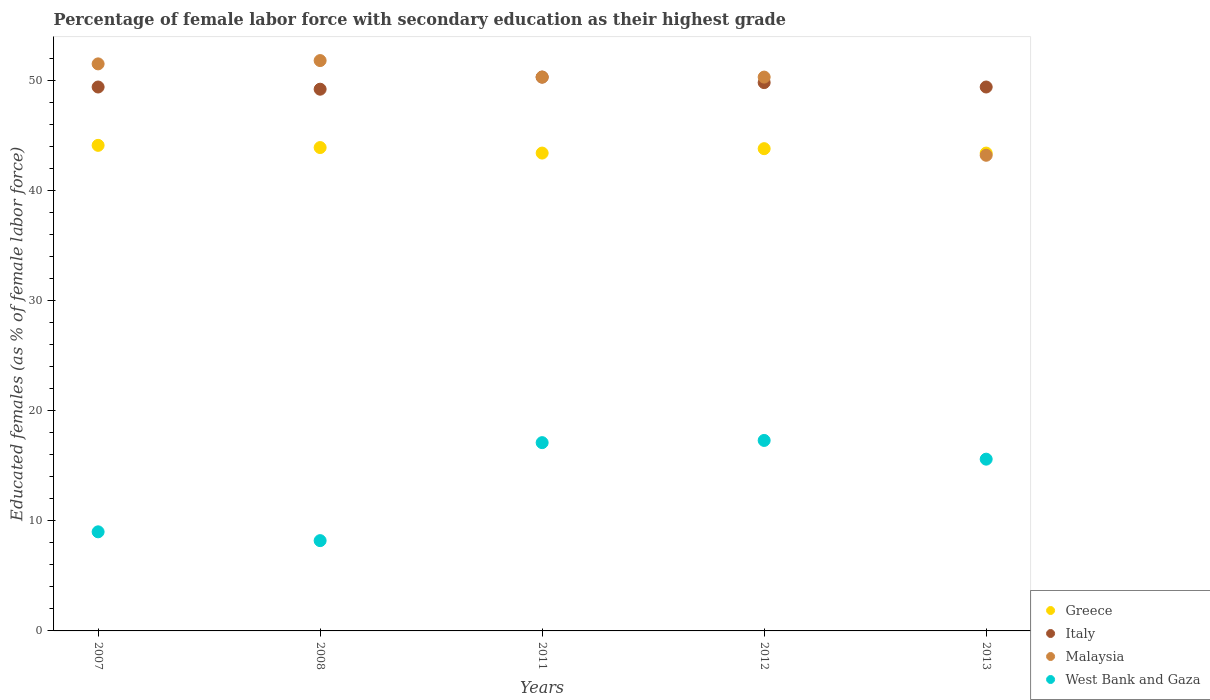Is the number of dotlines equal to the number of legend labels?
Make the answer very short. Yes. What is the percentage of female labor force with secondary education in Malaysia in 2013?
Offer a terse response. 43.2. Across all years, what is the maximum percentage of female labor force with secondary education in Italy?
Offer a very short reply. 50.3. Across all years, what is the minimum percentage of female labor force with secondary education in Italy?
Offer a terse response. 49.2. In which year was the percentage of female labor force with secondary education in Greece maximum?
Ensure brevity in your answer.  2007. In which year was the percentage of female labor force with secondary education in Italy minimum?
Your answer should be compact. 2008. What is the total percentage of female labor force with secondary education in West Bank and Gaza in the graph?
Provide a short and direct response. 67.2. What is the difference between the percentage of female labor force with secondary education in West Bank and Gaza in 2007 and that in 2013?
Ensure brevity in your answer.  -6.6. What is the difference between the percentage of female labor force with secondary education in West Bank and Gaza in 2011 and the percentage of female labor force with secondary education in Greece in 2012?
Make the answer very short. -26.7. What is the average percentage of female labor force with secondary education in Greece per year?
Keep it short and to the point. 43.72. In the year 2013, what is the difference between the percentage of female labor force with secondary education in Greece and percentage of female labor force with secondary education in West Bank and Gaza?
Provide a succinct answer. 27.8. In how many years, is the percentage of female labor force with secondary education in Malaysia greater than 26 %?
Your answer should be compact. 5. What is the ratio of the percentage of female labor force with secondary education in Greece in 2007 to that in 2008?
Offer a terse response. 1. Is the percentage of female labor force with secondary education in Italy in 2007 less than that in 2012?
Give a very brief answer. Yes. What is the difference between the highest and the second highest percentage of female labor force with secondary education in Greece?
Provide a succinct answer. 0.2. What is the difference between the highest and the lowest percentage of female labor force with secondary education in Malaysia?
Keep it short and to the point. 8.6. Is the sum of the percentage of female labor force with secondary education in West Bank and Gaza in 2011 and 2012 greater than the maximum percentage of female labor force with secondary education in Italy across all years?
Your answer should be very brief. No. Is it the case that in every year, the sum of the percentage of female labor force with secondary education in Malaysia and percentage of female labor force with secondary education in Italy  is greater than the sum of percentage of female labor force with secondary education in West Bank and Gaza and percentage of female labor force with secondary education in Greece?
Offer a very short reply. Yes. Does the percentage of female labor force with secondary education in West Bank and Gaza monotonically increase over the years?
Keep it short and to the point. No. Is the percentage of female labor force with secondary education in West Bank and Gaza strictly greater than the percentage of female labor force with secondary education in Greece over the years?
Ensure brevity in your answer.  No. What is the difference between two consecutive major ticks on the Y-axis?
Ensure brevity in your answer.  10. How many legend labels are there?
Provide a succinct answer. 4. How are the legend labels stacked?
Your answer should be very brief. Vertical. What is the title of the graph?
Provide a succinct answer. Percentage of female labor force with secondary education as their highest grade. What is the label or title of the X-axis?
Offer a very short reply. Years. What is the label or title of the Y-axis?
Offer a terse response. Educated females (as % of female labor force). What is the Educated females (as % of female labor force) in Greece in 2007?
Make the answer very short. 44.1. What is the Educated females (as % of female labor force) in Italy in 2007?
Give a very brief answer. 49.4. What is the Educated females (as % of female labor force) in Malaysia in 2007?
Offer a very short reply. 51.5. What is the Educated females (as % of female labor force) of West Bank and Gaza in 2007?
Your answer should be compact. 9. What is the Educated females (as % of female labor force) of Greece in 2008?
Provide a succinct answer. 43.9. What is the Educated females (as % of female labor force) in Italy in 2008?
Keep it short and to the point. 49.2. What is the Educated females (as % of female labor force) of Malaysia in 2008?
Give a very brief answer. 51.8. What is the Educated females (as % of female labor force) in West Bank and Gaza in 2008?
Provide a succinct answer. 8.2. What is the Educated females (as % of female labor force) in Greece in 2011?
Give a very brief answer. 43.4. What is the Educated females (as % of female labor force) of Italy in 2011?
Offer a very short reply. 50.3. What is the Educated females (as % of female labor force) of Malaysia in 2011?
Provide a short and direct response. 50.3. What is the Educated females (as % of female labor force) in West Bank and Gaza in 2011?
Offer a very short reply. 17.1. What is the Educated females (as % of female labor force) of Greece in 2012?
Ensure brevity in your answer.  43.8. What is the Educated females (as % of female labor force) of Italy in 2012?
Ensure brevity in your answer.  49.8. What is the Educated females (as % of female labor force) in Malaysia in 2012?
Provide a succinct answer. 50.3. What is the Educated females (as % of female labor force) of West Bank and Gaza in 2012?
Offer a very short reply. 17.3. What is the Educated females (as % of female labor force) in Greece in 2013?
Make the answer very short. 43.4. What is the Educated females (as % of female labor force) of Italy in 2013?
Provide a short and direct response. 49.4. What is the Educated females (as % of female labor force) in Malaysia in 2013?
Offer a very short reply. 43.2. What is the Educated females (as % of female labor force) of West Bank and Gaza in 2013?
Your response must be concise. 15.6. Across all years, what is the maximum Educated females (as % of female labor force) in Greece?
Keep it short and to the point. 44.1. Across all years, what is the maximum Educated females (as % of female labor force) of Italy?
Provide a succinct answer. 50.3. Across all years, what is the maximum Educated females (as % of female labor force) of Malaysia?
Your response must be concise. 51.8. Across all years, what is the maximum Educated females (as % of female labor force) in West Bank and Gaza?
Ensure brevity in your answer.  17.3. Across all years, what is the minimum Educated females (as % of female labor force) in Greece?
Provide a short and direct response. 43.4. Across all years, what is the minimum Educated females (as % of female labor force) in Italy?
Your response must be concise. 49.2. Across all years, what is the minimum Educated females (as % of female labor force) in Malaysia?
Give a very brief answer. 43.2. Across all years, what is the minimum Educated females (as % of female labor force) of West Bank and Gaza?
Keep it short and to the point. 8.2. What is the total Educated females (as % of female labor force) in Greece in the graph?
Offer a terse response. 218.6. What is the total Educated females (as % of female labor force) in Italy in the graph?
Provide a short and direct response. 248.1. What is the total Educated females (as % of female labor force) of Malaysia in the graph?
Your answer should be compact. 247.1. What is the total Educated females (as % of female labor force) of West Bank and Gaza in the graph?
Make the answer very short. 67.2. What is the difference between the Educated females (as % of female labor force) in Greece in 2007 and that in 2008?
Offer a very short reply. 0.2. What is the difference between the Educated females (as % of female labor force) in Italy in 2007 and that in 2008?
Provide a succinct answer. 0.2. What is the difference between the Educated females (as % of female labor force) of Malaysia in 2007 and that in 2008?
Make the answer very short. -0.3. What is the difference between the Educated females (as % of female labor force) of Greece in 2007 and that in 2011?
Offer a very short reply. 0.7. What is the difference between the Educated females (as % of female labor force) in Italy in 2007 and that in 2011?
Provide a short and direct response. -0.9. What is the difference between the Educated females (as % of female labor force) of Malaysia in 2007 and that in 2011?
Give a very brief answer. 1.2. What is the difference between the Educated females (as % of female labor force) of West Bank and Gaza in 2007 and that in 2011?
Provide a short and direct response. -8.1. What is the difference between the Educated females (as % of female labor force) in Malaysia in 2007 and that in 2012?
Your answer should be very brief. 1.2. What is the difference between the Educated females (as % of female labor force) of Italy in 2007 and that in 2013?
Provide a succinct answer. 0. What is the difference between the Educated females (as % of female labor force) in Malaysia in 2007 and that in 2013?
Offer a very short reply. 8.3. What is the difference between the Educated females (as % of female labor force) in West Bank and Gaza in 2007 and that in 2013?
Keep it short and to the point. -6.6. What is the difference between the Educated females (as % of female labor force) in Greece in 2008 and that in 2011?
Provide a short and direct response. 0.5. What is the difference between the Educated females (as % of female labor force) of Italy in 2008 and that in 2011?
Make the answer very short. -1.1. What is the difference between the Educated females (as % of female labor force) in West Bank and Gaza in 2008 and that in 2011?
Ensure brevity in your answer.  -8.9. What is the difference between the Educated females (as % of female labor force) of Greece in 2008 and that in 2012?
Your answer should be compact. 0.1. What is the difference between the Educated females (as % of female labor force) of Italy in 2008 and that in 2012?
Give a very brief answer. -0.6. What is the difference between the Educated females (as % of female labor force) of West Bank and Gaza in 2008 and that in 2012?
Offer a terse response. -9.1. What is the difference between the Educated females (as % of female labor force) of Greece in 2008 and that in 2013?
Ensure brevity in your answer.  0.5. What is the difference between the Educated females (as % of female labor force) in West Bank and Gaza in 2008 and that in 2013?
Your answer should be compact. -7.4. What is the difference between the Educated females (as % of female labor force) in Greece in 2011 and that in 2012?
Ensure brevity in your answer.  -0.4. What is the difference between the Educated females (as % of female labor force) of Greece in 2011 and that in 2013?
Keep it short and to the point. 0. What is the difference between the Educated females (as % of female labor force) in Greece in 2012 and that in 2013?
Offer a very short reply. 0.4. What is the difference between the Educated females (as % of female labor force) of Italy in 2012 and that in 2013?
Make the answer very short. 0.4. What is the difference between the Educated females (as % of female labor force) in Malaysia in 2012 and that in 2013?
Make the answer very short. 7.1. What is the difference between the Educated females (as % of female labor force) in Greece in 2007 and the Educated females (as % of female labor force) in Italy in 2008?
Provide a short and direct response. -5.1. What is the difference between the Educated females (as % of female labor force) of Greece in 2007 and the Educated females (as % of female labor force) of Malaysia in 2008?
Ensure brevity in your answer.  -7.7. What is the difference between the Educated females (as % of female labor force) of Greece in 2007 and the Educated females (as % of female labor force) of West Bank and Gaza in 2008?
Make the answer very short. 35.9. What is the difference between the Educated females (as % of female labor force) of Italy in 2007 and the Educated females (as % of female labor force) of Malaysia in 2008?
Offer a terse response. -2.4. What is the difference between the Educated females (as % of female labor force) of Italy in 2007 and the Educated females (as % of female labor force) of West Bank and Gaza in 2008?
Offer a very short reply. 41.2. What is the difference between the Educated females (as % of female labor force) in Malaysia in 2007 and the Educated females (as % of female labor force) in West Bank and Gaza in 2008?
Keep it short and to the point. 43.3. What is the difference between the Educated females (as % of female labor force) of Greece in 2007 and the Educated females (as % of female labor force) of Italy in 2011?
Your answer should be compact. -6.2. What is the difference between the Educated females (as % of female labor force) in Italy in 2007 and the Educated females (as % of female labor force) in Malaysia in 2011?
Provide a short and direct response. -0.9. What is the difference between the Educated females (as % of female labor force) of Italy in 2007 and the Educated females (as % of female labor force) of West Bank and Gaza in 2011?
Provide a short and direct response. 32.3. What is the difference between the Educated females (as % of female labor force) in Malaysia in 2007 and the Educated females (as % of female labor force) in West Bank and Gaza in 2011?
Provide a short and direct response. 34.4. What is the difference between the Educated females (as % of female labor force) in Greece in 2007 and the Educated females (as % of female labor force) in Italy in 2012?
Ensure brevity in your answer.  -5.7. What is the difference between the Educated females (as % of female labor force) in Greece in 2007 and the Educated females (as % of female labor force) in West Bank and Gaza in 2012?
Offer a terse response. 26.8. What is the difference between the Educated females (as % of female labor force) in Italy in 2007 and the Educated females (as % of female labor force) in Malaysia in 2012?
Offer a very short reply. -0.9. What is the difference between the Educated females (as % of female labor force) in Italy in 2007 and the Educated females (as % of female labor force) in West Bank and Gaza in 2012?
Your response must be concise. 32.1. What is the difference between the Educated females (as % of female labor force) of Malaysia in 2007 and the Educated females (as % of female labor force) of West Bank and Gaza in 2012?
Keep it short and to the point. 34.2. What is the difference between the Educated females (as % of female labor force) of Greece in 2007 and the Educated females (as % of female labor force) of Italy in 2013?
Your answer should be very brief. -5.3. What is the difference between the Educated females (as % of female labor force) in Greece in 2007 and the Educated females (as % of female labor force) in West Bank and Gaza in 2013?
Make the answer very short. 28.5. What is the difference between the Educated females (as % of female labor force) in Italy in 2007 and the Educated females (as % of female labor force) in Malaysia in 2013?
Your answer should be compact. 6.2. What is the difference between the Educated females (as % of female labor force) of Italy in 2007 and the Educated females (as % of female labor force) of West Bank and Gaza in 2013?
Provide a succinct answer. 33.8. What is the difference between the Educated females (as % of female labor force) in Malaysia in 2007 and the Educated females (as % of female labor force) in West Bank and Gaza in 2013?
Your response must be concise. 35.9. What is the difference between the Educated females (as % of female labor force) in Greece in 2008 and the Educated females (as % of female labor force) in Italy in 2011?
Make the answer very short. -6.4. What is the difference between the Educated females (as % of female labor force) of Greece in 2008 and the Educated females (as % of female labor force) of West Bank and Gaza in 2011?
Ensure brevity in your answer.  26.8. What is the difference between the Educated females (as % of female labor force) in Italy in 2008 and the Educated females (as % of female labor force) in Malaysia in 2011?
Provide a succinct answer. -1.1. What is the difference between the Educated females (as % of female labor force) in Italy in 2008 and the Educated females (as % of female labor force) in West Bank and Gaza in 2011?
Offer a very short reply. 32.1. What is the difference between the Educated females (as % of female labor force) in Malaysia in 2008 and the Educated females (as % of female labor force) in West Bank and Gaza in 2011?
Offer a terse response. 34.7. What is the difference between the Educated females (as % of female labor force) of Greece in 2008 and the Educated females (as % of female labor force) of Malaysia in 2012?
Ensure brevity in your answer.  -6.4. What is the difference between the Educated females (as % of female labor force) of Greece in 2008 and the Educated females (as % of female labor force) of West Bank and Gaza in 2012?
Offer a terse response. 26.6. What is the difference between the Educated females (as % of female labor force) in Italy in 2008 and the Educated females (as % of female labor force) in West Bank and Gaza in 2012?
Ensure brevity in your answer.  31.9. What is the difference between the Educated females (as % of female labor force) in Malaysia in 2008 and the Educated females (as % of female labor force) in West Bank and Gaza in 2012?
Your answer should be compact. 34.5. What is the difference between the Educated females (as % of female labor force) of Greece in 2008 and the Educated females (as % of female labor force) of Malaysia in 2013?
Your answer should be compact. 0.7. What is the difference between the Educated females (as % of female labor force) in Greece in 2008 and the Educated females (as % of female labor force) in West Bank and Gaza in 2013?
Make the answer very short. 28.3. What is the difference between the Educated females (as % of female labor force) of Italy in 2008 and the Educated females (as % of female labor force) of Malaysia in 2013?
Your response must be concise. 6. What is the difference between the Educated females (as % of female labor force) in Italy in 2008 and the Educated females (as % of female labor force) in West Bank and Gaza in 2013?
Your answer should be very brief. 33.6. What is the difference between the Educated females (as % of female labor force) in Malaysia in 2008 and the Educated females (as % of female labor force) in West Bank and Gaza in 2013?
Give a very brief answer. 36.2. What is the difference between the Educated females (as % of female labor force) of Greece in 2011 and the Educated females (as % of female labor force) of Malaysia in 2012?
Your answer should be very brief. -6.9. What is the difference between the Educated females (as % of female labor force) of Greece in 2011 and the Educated females (as % of female labor force) of West Bank and Gaza in 2012?
Provide a succinct answer. 26.1. What is the difference between the Educated females (as % of female labor force) of Malaysia in 2011 and the Educated females (as % of female labor force) of West Bank and Gaza in 2012?
Your answer should be compact. 33. What is the difference between the Educated females (as % of female labor force) of Greece in 2011 and the Educated females (as % of female labor force) of Italy in 2013?
Offer a terse response. -6. What is the difference between the Educated females (as % of female labor force) of Greece in 2011 and the Educated females (as % of female labor force) of Malaysia in 2013?
Provide a short and direct response. 0.2. What is the difference between the Educated females (as % of female labor force) in Greece in 2011 and the Educated females (as % of female labor force) in West Bank and Gaza in 2013?
Provide a short and direct response. 27.8. What is the difference between the Educated females (as % of female labor force) in Italy in 2011 and the Educated females (as % of female labor force) in Malaysia in 2013?
Offer a terse response. 7.1. What is the difference between the Educated females (as % of female labor force) in Italy in 2011 and the Educated females (as % of female labor force) in West Bank and Gaza in 2013?
Your answer should be compact. 34.7. What is the difference between the Educated females (as % of female labor force) in Malaysia in 2011 and the Educated females (as % of female labor force) in West Bank and Gaza in 2013?
Offer a terse response. 34.7. What is the difference between the Educated females (as % of female labor force) in Greece in 2012 and the Educated females (as % of female labor force) in West Bank and Gaza in 2013?
Provide a short and direct response. 28.2. What is the difference between the Educated females (as % of female labor force) of Italy in 2012 and the Educated females (as % of female labor force) of Malaysia in 2013?
Provide a short and direct response. 6.6. What is the difference between the Educated females (as % of female labor force) in Italy in 2012 and the Educated females (as % of female labor force) in West Bank and Gaza in 2013?
Provide a succinct answer. 34.2. What is the difference between the Educated females (as % of female labor force) in Malaysia in 2012 and the Educated females (as % of female labor force) in West Bank and Gaza in 2013?
Keep it short and to the point. 34.7. What is the average Educated females (as % of female labor force) of Greece per year?
Ensure brevity in your answer.  43.72. What is the average Educated females (as % of female labor force) of Italy per year?
Keep it short and to the point. 49.62. What is the average Educated females (as % of female labor force) in Malaysia per year?
Give a very brief answer. 49.42. What is the average Educated females (as % of female labor force) of West Bank and Gaza per year?
Ensure brevity in your answer.  13.44. In the year 2007, what is the difference between the Educated females (as % of female labor force) of Greece and Educated females (as % of female labor force) of Italy?
Offer a terse response. -5.3. In the year 2007, what is the difference between the Educated females (as % of female labor force) in Greece and Educated females (as % of female labor force) in Malaysia?
Your answer should be compact. -7.4. In the year 2007, what is the difference between the Educated females (as % of female labor force) in Greece and Educated females (as % of female labor force) in West Bank and Gaza?
Keep it short and to the point. 35.1. In the year 2007, what is the difference between the Educated females (as % of female labor force) of Italy and Educated females (as % of female labor force) of West Bank and Gaza?
Provide a short and direct response. 40.4. In the year 2007, what is the difference between the Educated females (as % of female labor force) of Malaysia and Educated females (as % of female labor force) of West Bank and Gaza?
Give a very brief answer. 42.5. In the year 2008, what is the difference between the Educated females (as % of female labor force) in Greece and Educated females (as % of female labor force) in Malaysia?
Provide a short and direct response. -7.9. In the year 2008, what is the difference between the Educated females (as % of female labor force) of Greece and Educated females (as % of female labor force) of West Bank and Gaza?
Your response must be concise. 35.7. In the year 2008, what is the difference between the Educated females (as % of female labor force) in Italy and Educated females (as % of female labor force) in West Bank and Gaza?
Provide a short and direct response. 41. In the year 2008, what is the difference between the Educated females (as % of female labor force) of Malaysia and Educated females (as % of female labor force) of West Bank and Gaza?
Provide a succinct answer. 43.6. In the year 2011, what is the difference between the Educated females (as % of female labor force) of Greece and Educated females (as % of female labor force) of West Bank and Gaza?
Offer a terse response. 26.3. In the year 2011, what is the difference between the Educated females (as % of female labor force) of Italy and Educated females (as % of female labor force) of West Bank and Gaza?
Offer a very short reply. 33.2. In the year 2011, what is the difference between the Educated females (as % of female labor force) of Malaysia and Educated females (as % of female labor force) of West Bank and Gaza?
Give a very brief answer. 33.2. In the year 2012, what is the difference between the Educated females (as % of female labor force) in Greece and Educated females (as % of female labor force) in Malaysia?
Give a very brief answer. -6.5. In the year 2012, what is the difference between the Educated females (as % of female labor force) of Greece and Educated females (as % of female labor force) of West Bank and Gaza?
Offer a very short reply. 26.5. In the year 2012, what is the difference between the Educated females (as % of female labor force) in Italy and Educated females (as % of female labor force) in Malaysia?
Your answer should be compact. -0.5. In the year 2012, what is the difference between the Educated females (as % of female labor force) of Italy and Educated females (as % of female labor force) of West Bank and Gaza?
Offer a very short reply. 32.5. In the year 2012, what is the difference between the Educated females (as % of female labor force) in Malaysia and Educated females (as % of female labor force) in West Bank and Gaza?
Your response must be concise. 33. In the year 2013, what is the difference between the Educated females (as % of female labor force) of Greece and Educated females (as % of female labor force) of Italy?
Your answer should be compact. -6. In the year 2013, what is the difference between the Educated females (as % of female labor force) in Greece and Educated females (as % of female labor force) in Malaysia?
Provide a short and direct response. 0.2. In the year 2013, what is the difference between the Educated females (as % of female labor force) of Greece and Educated females (as % of female labor force) of West Bank and Gaza?
Provide a succinct answer. 27.8. In the year 2013, what is the difference between the Educated females (as % of female labor force) of Italy and Educated females (as % of female labor force) of Malaysia?
Offer a very short reply. 6.2. In the year 2013, what is the difference between the Educated females (as % of female labor force) in Italy and Educated females (as % of female labor force) in West Bank and Gaza?
Give a very brief answer. 33.8. In the year 2013, what is the difference between the Educated females (as % of female labor force) of Malaysia and Educated females (as % of female labor force) of West Bank and Gaza?
Make the answer very short. 27.6. What is the ratio of the Educated females (as % of female labor force) of Italy in 2007 to that in 2008?
Make the answer very short. 1. What is the ratio of the Educated females (as % of female labor force) of West Bank and Gaza in 2007 to that in 2008?
Keep it short and to the point. 1.1. What is the ratio of the Educated females (as % of female labor force) in Greece in 2007 to that in 2011?
Make the answer very short. 1.02. What is the ratio of the Educated females (as % of female labor force) in Italy in 2007 to that in 2011?
Provide a succinct answer. 0.98. What is the ratio of the Educated females (as % of female labor force) in Malaysia in 2007 to that in 2011?
Keep it short and to the point. 1.02. What is the ratio of the Educated females (as % of female labor force) of West Bank and Gaza in 2007 to that in 2011?
Make the answer very short. 0.53. What is the ratio of the Educated females (as % of female labor force) of Greece in 2007 to that in 2012?
Provide a succinct answer. 1.01. What is the ratio of the Educated females (as % of female labor force) in Malaysia in 2007 to that in 2012?
Your response must be concise. 1.02. What is the ratio of the Educated females (as % of female labor force) of West Bank and Gaza in 2007 to that in 2012?
Provide a short and direct response. 0.52. What is the ratio of the Educated females (as % of female labor force) of Greece in 2007 to that in 2013?
Make the answer very short. 1.02. What is the ratio of the Educated females (as % of female labor force) of Italy in 2007 to that in 2013?
Offer a terse response. 1. What is the ratio of the Educated females (as % of female labor force) of Malaysia in 2007 to that in 2013?
Keep it short and to the point. 1.19. What is the ratio of the Educated females (as % of female labor force) in West Bank and Gaza in 2007 to that in 2013?
Your answer should be compact. 0.58. What is the ratio of the Educated females (as % of female labor force) in Greece in 2008 to that in 2011?
Provide a succinct answer. 1.01. What is the ratio of the Educated females (as % of female labor force) in Italy in 2008 to that in 2011?
Offer a very short reply. 0.98. What is the ratio of the Educated females (as % of female labor force) of Malaysia in 2008 to that in 2011?
Make the answer very short. 1.03. What is the ratio of the Educated females (as % of female labor force) of West Bank and Gaza in 2008 to that in 2011?
Offer a terse response. 0.48. What is the ratio of the Educated females (as % of female labor force) of Malaysia in 2008 to that in 2012?
Ensure brevity in your answer.  1.03. What is the ratio of the Educated females (as % of female labor force) in West Bank and Gaza in 2008 to that in 2012?
Offer a terse response. 0.47. What is the ratio of the Educated females (as % of female labor force) of Greece in 2008 to that in 2013?
Your answer should be very brief. 1.01. What is the ratio of the Educated females (as % of female labor force) of Malaysia in 2008 to that in 2013?
Make the answer very short. 1.2. What is the ratio of the Educated females (as % of female labor force) of West Bank and Gaza in 2008 to that in 2013?
Your answer should be very brief. 0.53. What is the ratio of the Educated females (as % of female labor force) in Greece in 2011 to that in 2012?
Offer a very short reply. 0.99. What is the ratio of the Educated females (as % of female labor force) of West Bank and Gaza in 2011 to that in 2012?
Your answer should be very brief. 0.99. What is the ratio of the Educated females (as % of female labor force) in Italy in 2011 to that in 2013?
Offer a terse response. 1.02. What is the ratio of the Educated females (as % of female labor force) of Malaysia in 2011 to that in 2013?
Keep it short and to the point. 1.16. What is the ratio of the Educated females (as % of female labor force) in West Bank and Gaza in 2011 to that in 2013?
Your response must be concise. 1.1. What is the ratio of the Educated females (as % of female labor force) in Greece in 2012 to that in 2013?
Your answer should be compact. 1.01. What is the ratio of the Educated females (as % of female labor force) of Italy in 2012 to that in 2013?
Offer a very short reply. 1.01. What is the ratio of the Educated females (as % of female labor force) of Malaysia in 2012 to that in 2013?
Your answer should be compact. 1.16. What is the ratio of the Educated females (as % of female labor force) in West Bank and Gaza in 2012 to that in 2013?
Offer a terse response. 1.11. What is the difference between the highest and the second highest Educated females (as % of female labor force) of Greece?
Provide a succinct answer. 0.2. What is the difference between the highest and the second highest Educated females (as % of female labor force) in Malaysia?
Your response must be concise. 0.3. What is the difference between the highest and the lowest Educated females (as % of female labor force) of Malaysia?
Give a very brief answer. 8.6. What is the difference between the highest and the lowest Educated females (as % of female labor force) in West Bank and Gaza?
Your response must be concise. 9.1. 